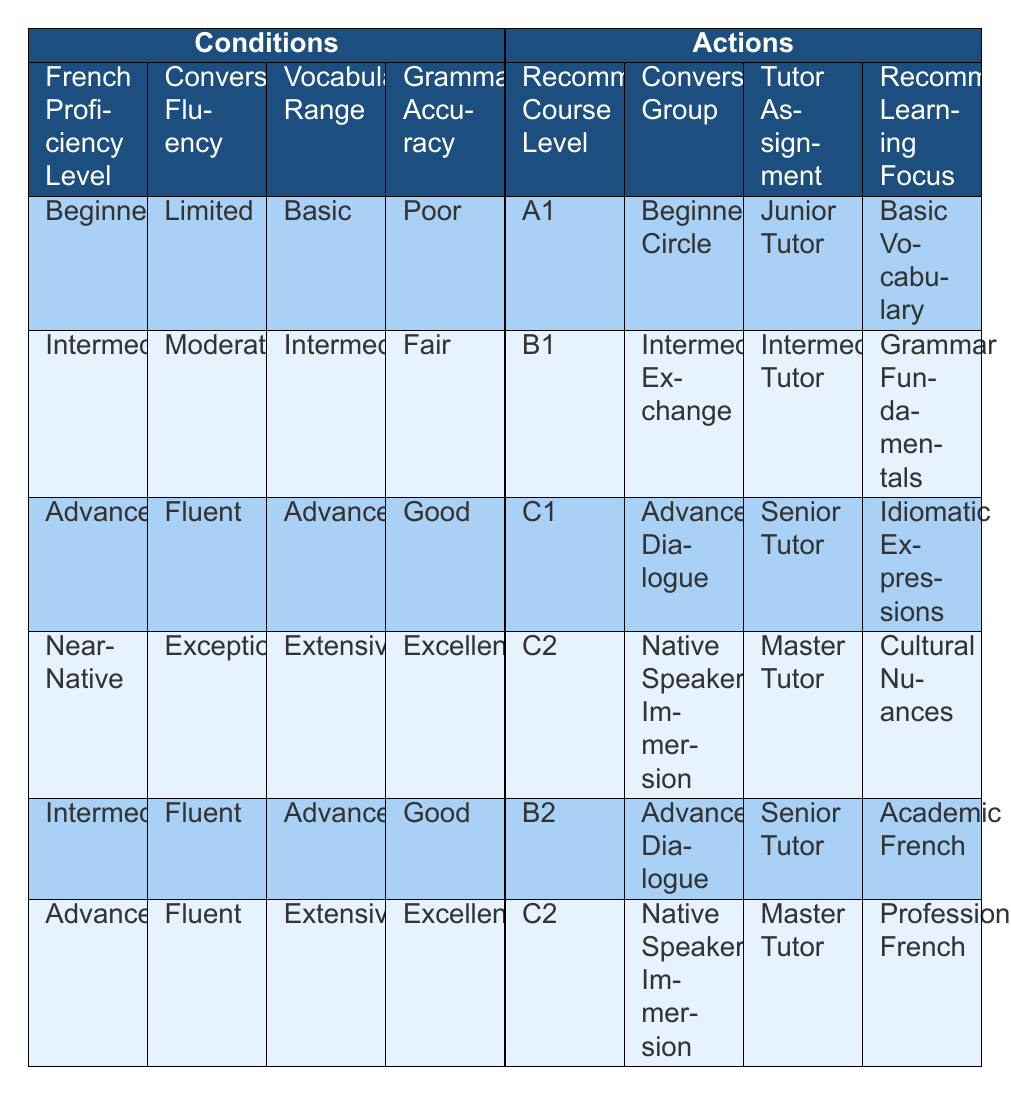What is the recommended course level for a student with a French proficiency level of Intermediate, conversational fluency of Moderate, vocabulary range of Intermediate, and grammar accuracy of Fair? Looking at the table, under the conditions of "Intermediate," "Moderate," "Intermediate," and "Fair," the corresponding recommended course level is "B1."
Answer: B1 What is the conversation group assigned to students who are Near-Native speakers with Exceptional conversational fluency? According to the table, students who fall under the conditions of "Near-Native" proficiency and "Exceptional" fluency will be assigned to the "Native Speaker Immersion" group.
Answer: Native Speaker Immersion Is it true that a student with poor grammar accuracy is assigned to the C1 course level? Reviewing the table, the conditions associated with the C1 course level include both Advanced proficiency and Good grammar accuracy. Since poor grammar does not meet these conditions, the statement is false.
Answer: No Which tutor is assigned to students who are Advanced learners with Fluent conversational skills and Extensive vocabulary? From the table, students categorized as "Advanced," with "Fluent" skills and "Extensive" vocabulary, are assigned to a "Master Tutor."
Answer: Master Tutor How many courses are assigned to students with Intermediate proficiency but different levels of conversational fluency? Analyzing the table, there are 2 courses assigned to Intermediate proficiency; "B1" for Moderate fluency and "B2" for Fluent fluency, making a total of 2 courses.
Answer: 2 What is the recommended learning focus for students who are classified as Beginners? From the table, when students are categorized as "Beginner" with "Limited" fluency, their recommended learning focus is on "Basic Vocabulary."
Answer: Basic Vocabulary If a student's vocabulary range is Advanced with Good grammar accuracy, which conversation group would they belong to? According to the table, students with "Advanced" vocabulary and "Good" grammar accuracy fall under the conditions for "B2," which corresponds to the "Advanced Dialogue" conversation group.
Answer: Advanced Dialogue For students at C2 level, which tutor is typically assigned for Cultural Nuances? Referring to the table, students at "C2" level with conditions that include "Exceptional" fluency and "Extensive" vocabulary will be assigned a "Master Tutor" focusing on "Cultural Nuances."
Answer: Master Tutor 